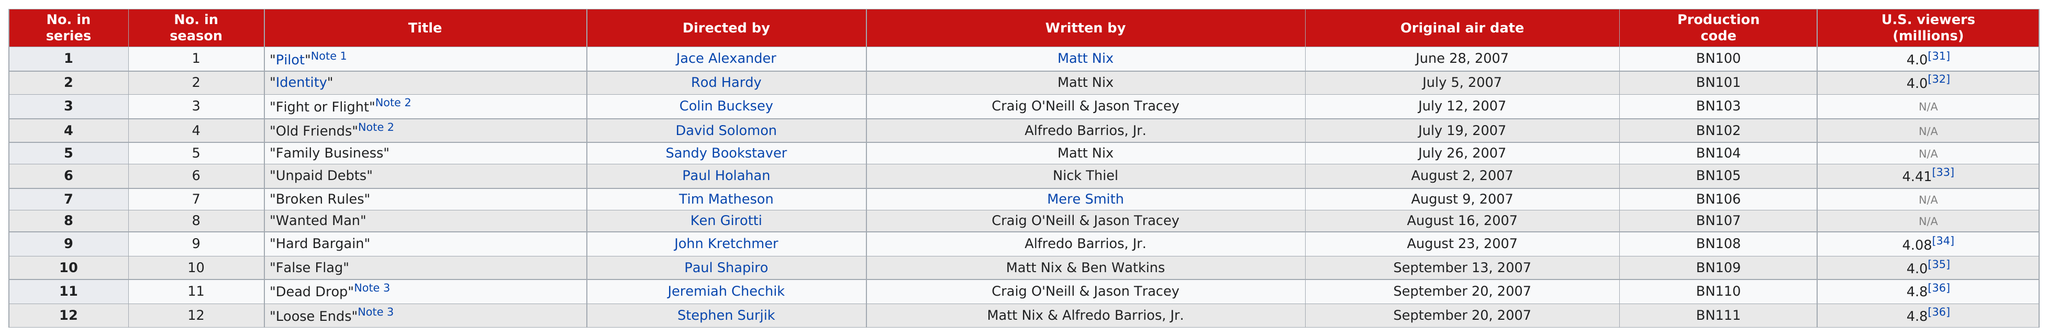Give some essential details in this illustration. The total number of episodes written by Craig O'Neill is 3. The first episode of the series was viewed by 4.0 million U.S. viewers. Episode 10 of a series was broadcasted 21 days after episode 9. Matt Nix wrote 5 episodes. In episode 10, the episode was written by Matt, Nix, and Ben Watkins. 